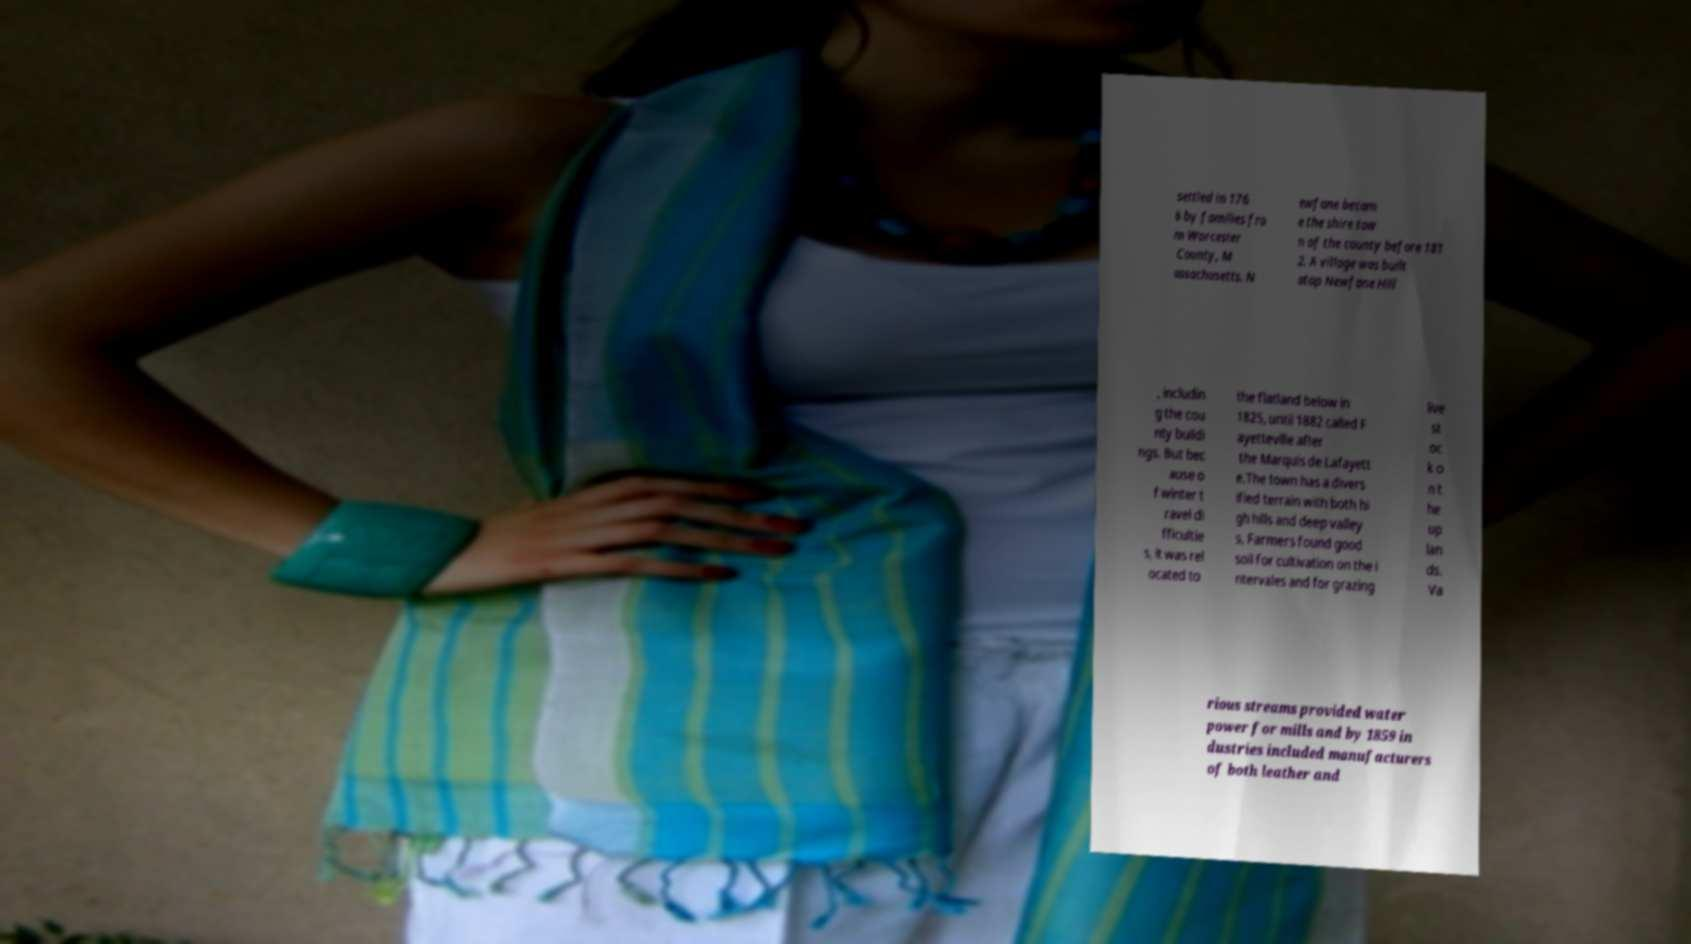I need the written content from this picture converted into text. Can you do that? settled in 176 6 by families fro m Worcester County, M assachusetts. N ewfane becam e the shire tow n of the county before 181 2. A village was built atop Newfane Hill , includin g the cou nty buildi ngs. But bec ause o f winter t ravel di fficultie s, it was rel ocated to the flatland below in 1825, until 1882 called F ayetteville after the Marquis de Lafayett e.The town has a divers ified terrain with both hi gh hills and deep valley s. Farmers found good soil for cultivation on the i ntervales and for grazing live st oc k o n t he up lan ds. Va rious streams provided water power for mills and by 1859 in dustries included manufacturers of both leather and 